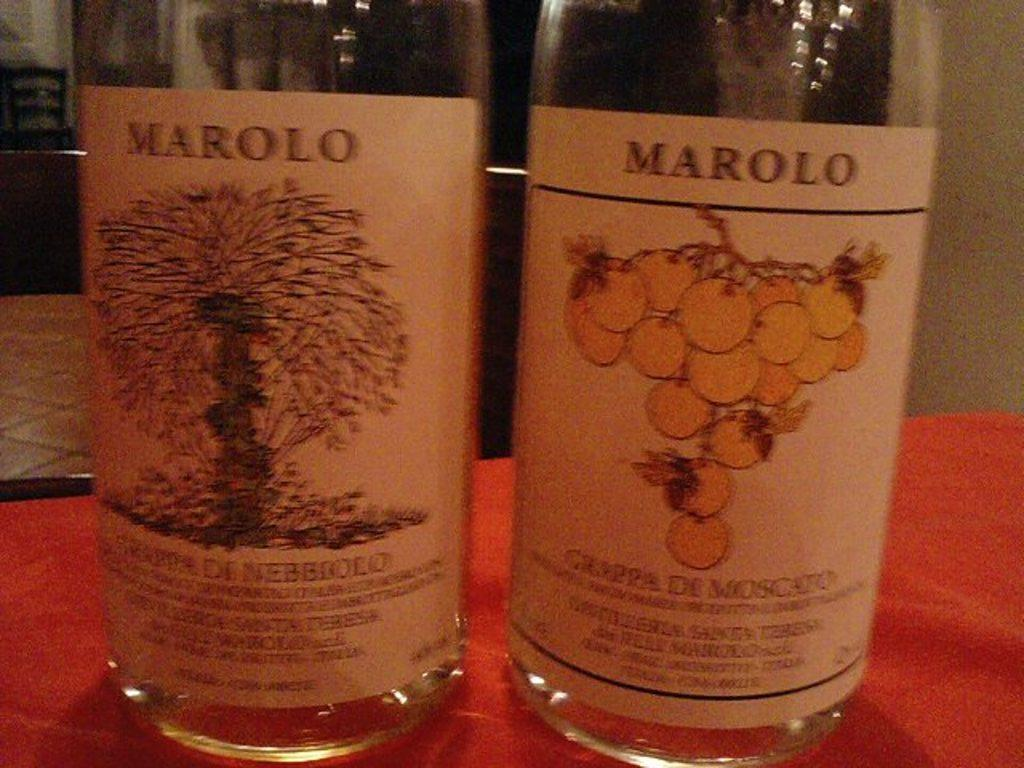Provide a one-sentence caption for the provided image. The wine bottles show two different images of wine made by Marolo. 